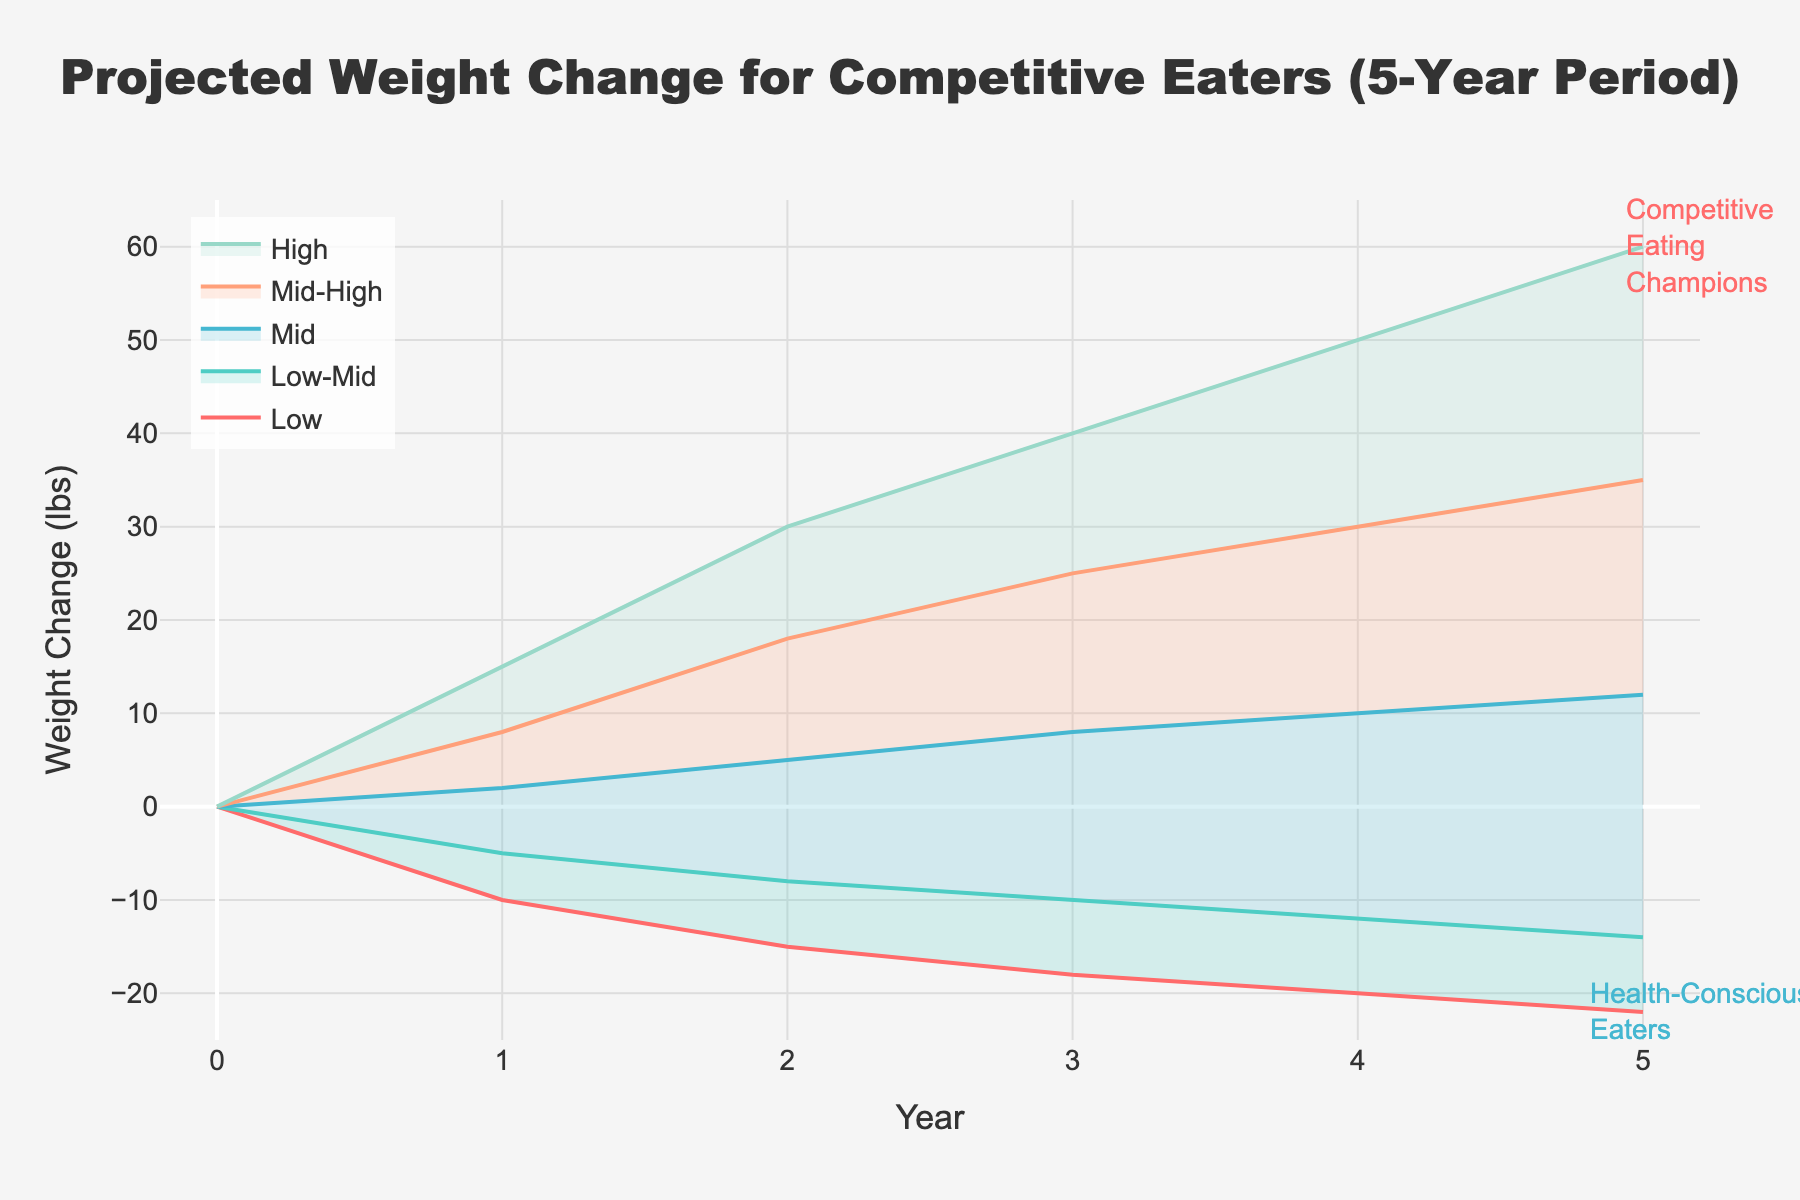How many distinct colored lines are there in the chart? The chart shows projections for 5 categories ("Low", "Low-Mid", "Mid", "Mid-High", and "High"). Each category is represented by a distinct color.
Answer: 5 What is the projected weight change for the "Mid" category in year 3? Looking at the "Mid" category in year 3, the chart indicates a weight change value of 8 lbs.
Answer: 8 lbs What is the difference in projected weight change between the "High" and "Low" categories in year 5? In year 5, the "High" category is projected at 60 lbs, and the "Low" category at -22 lbs. The difference is 60 - (-22) = 82 lbs.
Answer: 82 lbs What is the trend for the "Low-Mid" category over the 5-year period? The "Low-Mid" category starts at 0 lbs (year 0), then proceeds -5, -8, -10, -12, and -14 lbs over the years, showing a consistently decreasing trend.
Answer: Decreasing Which category has the highest projected weight gain in year 4? The "High" category shows the highest projected weight gain in year 4 with a value of 50 lbs.
Answer: "High" category What is the average projected weight change for the "Mid-High" category over the 5 years? The "Mid-High" category projections for the 5 years are 0, 8, 18, 25, 30, and 35 lbs. Average = (0 + 8 + 18 + 25 + 30 + 35) / 6 = 116 / 6 ≈ 19.33 lbs.
Answer: 19.33 lbs How many years show a negative weight change for the "Low" category? The "Low" category shows negative weight changes for each of the 5 years shown in the chart (-10, -15, -18, -20, -22).
Answer: 5 years Is there any year where the "Mid" category shows a negative weight change? A negative weight change in the "Mid" category is seen in year 1 with a value of 2 lbs, which is positive. Hence, "Mid" shows only positive values.
Answer: No Which categories have more than 10 lbs weight change in year 5? In year 5, only "Mid-High" and "High" categories surpass 10 lbs in weight change, with values of 35 lbs and 60 lbs, respectively.
Answer: "Mid-High" and "High" categories In which year does the "Mid-High" category show the highest weight gain increment compared to the previous year? Year 2 to 3, the "Mid-High" category projections go from 18 lbs to 25 lbs, which is an increment of 7 lbs, the highest increment compared to other years.
Answer: Year 2 to 3 